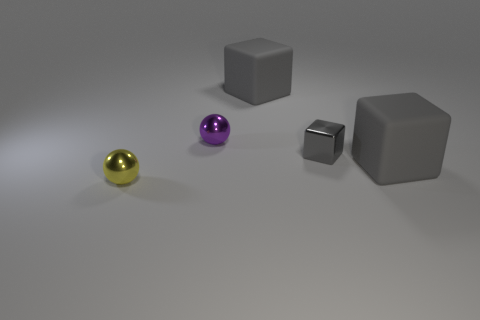Add 4 metal things. How many objects exist? 9 Subtract all spheres. How many objects are left? 3 Add 2 small purple metallic objects. How many small purple metallic objects are left? 3 Add 4 large green cylinders. How many large green cylinders exist? 4 Subtract 0 cyan blocks. How many objects are left? 5 Subtract all brown balls. Subtract all matte objects. How many objects are left? 3 